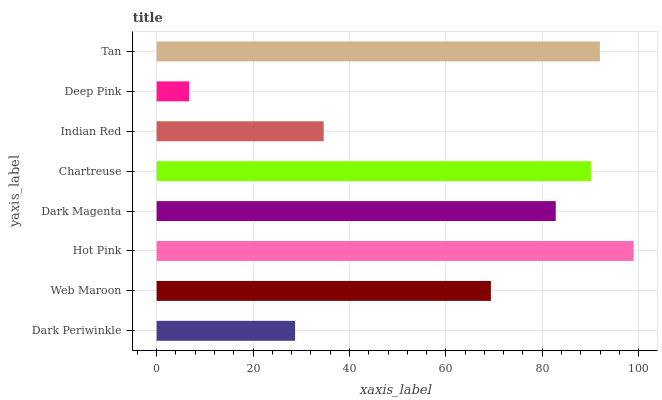Is Deep Pink the minimum?
Answer yes or no. Yes. Is Hot Pink the maximum?
Answer yes or no. Yes. Is Web Maroon the minimum?
Answer yes or no. No. Is Web Maroon the maximum?
Answer yes or no. No. Is Web Maroon greater than Dark Periwinkle?
Answer yes or no. Yes. Is Dark Periwinkle less than Web Maroon?
Answer yes or no. Yes. Is Dark Periwinkle greater than Web Maroon?
Answer yes or no. No. Is Web Maroon less than Dark Periwinkle?
Answer yes or no. No. Is Dark Magenta the high median?
Answer yes or no. Yes. Is Web Maroon the low median?
Answer yes or no. Yes. Is Indian Red the high median?
Answer yes or no. No. Is Tan the low median?
Answer yes or no. No. 